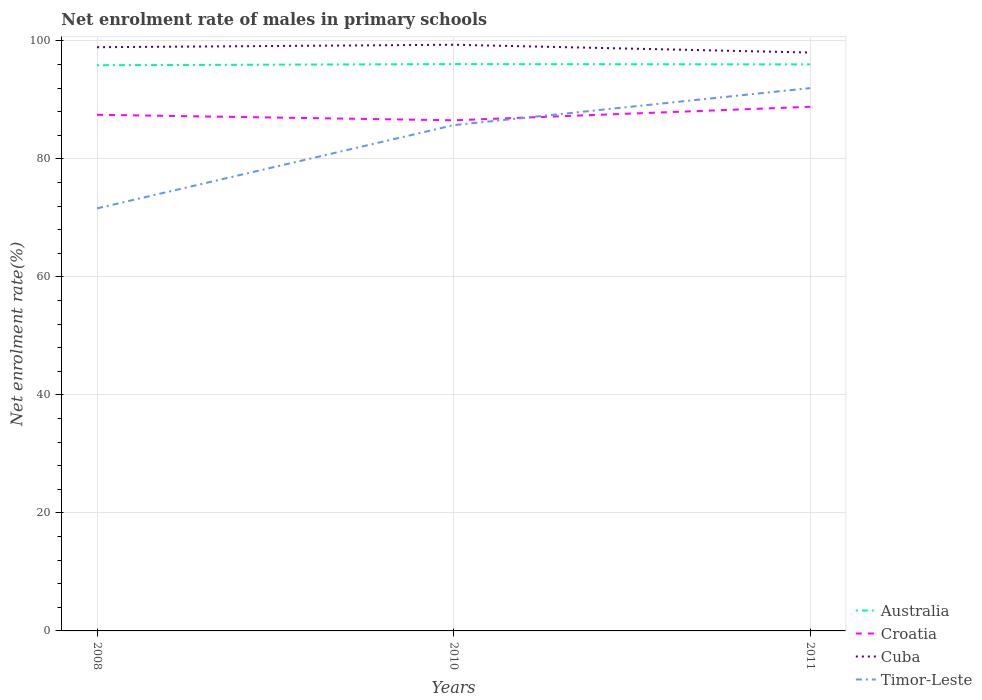How many different coloured lines are there?
Make the answer very short. 4. Across all years, what is the maximum net enrolment rate of males in primary schools in Croatia?
Keep it short and to the point. 86.55. What is the total net enrolment rate of males in primary schools in Timor-Leste in the graph?
Make the answer very short. -20.39. What is the difference between the highest and the second highest net enrolment rate of males in primary schools in Cuba?
Give a very brief answer. 1.32. How many years are there in the graph?
Keep it short and to the point. 3. Are the values on the major ticks of Y-axis written in scientific E-notation?
Your answer should be compact. No. Does the graph contain any zero values?
Ensure brevity in your answer.  No. Does the graph contain grids?
Provide a short and direct response. Yes. Where does the legend appear in the graph?
Your response must be concise. Bottom right. How many legend labels are there?
Keep it short and to the point. 4. What is the title of the graph?
Your answer should be compact. Net enrolment rate of males in primary schools. What is the label or title of the X-axis?
Ensure brevity in your answer.  Years. What is the label or title of the Y-axis?
Make the answer very short. Net enrolment rate(%). What is the Net enrolment rate(%) in Australia in 2008?
Ensure brevity in your answer.  95.89. What is the Net enrolment rate(%) in Croatia in 2008?
Provide a short and direct response. 87.49. What is the Net enrolment rate(%) in Cuba in 2008?
Your response must be concise. 98.94. What is the Net enrolment rate(%) in Timor-Leste in 2008?
Make the answer very short. 71.63. What is the Net enrolment rate(%) in Australia in 2010?
Your response must be concise. 96.09. What is the Net enrolment rate(%) in Croatia in 2010?
Provide a succinct answer. 86.55. What is the Net enrolment rate(%) of Cuba in 2010?
Your answer should be very brief. 99.36. What is the Net enrolment rate(%) in Timor-Leste in 2010?
Your response must be concise. 85.73. What is the Net enrolment rate(%) in Australia in 2011?
Your answer should be very brief. 96.03. What is the Net enrolment rate(%) in Croatia in 2011?
Keep it short and to the point. 88.85. What is the Net enrolment rate(%) of Cuba in 2011?
Keep it short and to the point. 98.04. What is the Net enrolment rate(%) in Timor-Leste in 2011?
Offer a very short reply. 92.02. Across all years, what is the maximum Net enrolment rate(%) of Australia?
Keep it short and to the point. 96.09. Across all years, what is the maximum Net enrolment rate(%) in Croatia?
Your response must be concise. 88.85. Across all years, what is the maximum Net enrolment rate(%) in Cuba?
Make the answer very short. 99.36. Across all years, what is the maximum Net enrolment rate(%) in Timor-Leste?
Ensure brevity in your answer.  92.02. Across all years, what is the minimum Net enrolment rate(%) of Australia?
Offer a very short reply. 95.89. Across all years, what is the minimum Net enrolment rate(%) in Croatia?
Provide a succinct answer. 86.55. Across all years, what is the minimum Net enrolment rate(%) in Cuba?
Keep it short and to the point. 98.04. Across all years, what is the minimum Net enrolment rate(%) of Timor-Leste?
Ensure brevity in your answer.  71.63. What is the total Net enrolment rate(%) in Australia in the graph?
Provide a succinct answer. 288.01. What is the total Net enrolment rate(%) in Croatia in the graph?
Provide a short and direct response. 262.89. What is the total Net enrolment rate(%) of Cuba in the graph?
Provide a short and direct response. 296.35. What is the total Net enrolment rate(%) of Timor-Leste in the graph?
Provide a succinct answer. 249.37. What is the difference between the Net enrolment rate(%) of Australia in 2008 and that in 2010?
Your answer should be very brief. -0.2. What is the difference between the Net enrolment rate(%) of Croatia in 2008 and that in 2010?
Your response must be concise. 0.94. What is the difference between the Net enrolment rate(%) in Cuba in 2008 and that in 2010?
Make the answer very short. -0.42. What is the difference between the Net enrolment rate(%) of Timor-Leste in 2008 and that in 2010?
Make the answer very short. -14.11. What is the difference between the Net enrolment rate(%) in Australia in 2008 and that in 2011?
Provide a short and direct response. -0.15. What is the difference between the Net enrolment rate(%) of Croatia in 2008 and that in 2011?
Ensure brevity in your answer.  -1.36. What is the difference between the Net enrolment rate(%) in Cuba in 2008 and that in 2011?
Offer a very short reply. 0.9. What is the difference between the Net enrolment rate(%) of Timor-Leste in 2008 and that in 2011?
Offer a terse response. -20.39. What is the difference between the Net enrolment rate(%) of Australia in 2010 and that in 2011?
Make the answer very short. 0.05. What is the difference between the Net enrolment rate(%) of Croatia in 2010 and that in 2011?
Provide a short and direct response. -2.29. What is the difference between the Net enrolment rate(%) of Cuba in 2010 and that in 2011?
Ensure brevity in your answer.  1.32. What is the difference between the Net enrolment rate(%) in Timor-Leste in 2010 and that in 2011?
Your response must be concise. -6.28. What is the difference between the Net enrolment rate(%) of Australia in 2008 and the Net enrolment rate(%) of Croatia in 2010?
Provide a succinct answer. 9.33. What is the difference between the Net enrolment rate(%) in Australia in 2008 and the Net enrolment rate(%) in Cuba in 2010?
Your response must be concise. -3.47. What is the difference between the Net enrolment rate(%) in Australia in 2008 and the Net enrolment rate(%) in Timor-Leste in 2010?
Provide a succinct answer. 10.16. What is the difference between the Net enrolment rate(%) in Croatia in 2008 and the Net enrolment rate(%) in Cuba in 2010?
Make the answer very short. -11.87. What is the difference between the Net enrolment rate(%) of Croatia in 2008 and the Net enrolment rate(%) of Timor-Leste in 2010?
Your answer should be compact. 1.76. What is the difference between the Net enrolment rate(%) in Cuba in 2008 and the Net enrolment rate(%) in Timor-Leste in 2010?
Ensure brevity in your answer.  13.21. What is the difference between the Net enrolment rate(%) in Australia in 2008 and the Net enrolment rate(%) in Croatia in 2011?
Your answer should be very brief. 7.04. What is the difference between the Net enrolment rate(%) in Australia in 2008 and the Net enrolment rate(%) in Cuba in 2011?
Offer a very short reply. -2.15. What is the difference between the Net enrolment rate(%) in Australia in 2008 and the Net enrolment rate(%) in Timor-Leste in 2011?
Your answer should be very brief. 3.87. What is the difference between the Net enrolment rate(%) in Croatia in 2008 and the Net enrolment rate(%) in Cuba in 2011?
Make the answer very short. -10.55. What is the difference between the Net enrolment rate(%) in Croatia in 2008 and the Net enrolment rate(%) in Timor-Leste in 2011?
Offer a very short reply. -4.53. What is the difference between the Net enrolment rate(%) of Cuba in 2008 and the Net enrolment rate(%) of Timor-Leste in 2011?
Keep it short and to the point. 6.93. What is the difference between the Net enrolment rate(%) of Australia in 2010 and the Net enrolment rate(%) of Croatia in 2011?
Keep it short and to the point. 7.24. What is the difference between the Net enrolment rate(%) of Australia in 2010 and the Net enrolment rate(%) of Cuba in 2011?
Provide a short and direct response. -1.96. What is the difference between the Net enrolment rate(%) in Australia in 2010 and the Net enrolment rate(%) in Timor-Leste in 2011?
Provide a short and direct response. 4.07. What is the difference between the Net enrolment rate(%) of Croatia in 2010 and the Net enrolment rate(%) of Cuba in 2011?
Your response must be concise. -11.49. What is the difference between the Net enrolment rate(%) in Croatia in 2010 and the Net enrolment rate(%) in Timor-Leste in 2011?
Ensure brevity in your answer.  -5.46. What is the difference between the Net enrolment rate(%) in Cuba in 2010 and the Net enrolment rate(%) in Timor-Leste in 2011?
Your answer should be very brief. 7.35. What is the average Net enrolment rate(%) in Australia per year?
Your response must be concise. 96. What is the average Net enrolment rate(%) of Croatia per year?
Offer a terse response. 87.63. What is the average Net enrolment rate(%) in Cuba per year?
Offer a terse response. 98.78. What is the average Net enrolment rate(%) of Timor-Leste per year?
Give a very brief answer. 83.12. In the year 2008, what is the difference between the Net enrolment rate(%) of Australia and Net enrolment rate(%) of Croatia?
Offer a very short reply. 8.4. In the year 2008, what is the difference between the Net enrolment rate(%) of Australia and Net enrolment rate(%) of Cuba?
Your answer should be very brief. -3.06. In the year 2008, what is the difference between the Net enrolment rate(%) in Australia and Net enrolment rate(%) in Timor-Leste?
Offer a very short reply. 24.26. In the year 2008, what is the difference between the Net enrolment rate(%) in Croatia and Net enrolment rate(%) in Cuba?
Your answer should be compact. -11.45. In the year 2008, what is the difference between the Net enrolment rate(%) in Croatia and Net enrolment rate(%) in Timor-Leste?
Keep it short and to the point. 15.86. In the year 2008, what is the difference between the Net enrolment rate(%) of Cuba and Net enrolment rate(%) of Timor-Leste?
Make the answer very short. 27.32. In the year 2010, what is the difference between the Net enrolment rate(%) in Australia and Net enrolment rate(%) in Croatia?
Provide a short and direct response. 9.53. In the year 2010, what is the difference between the Net enrolment rate(%) of Australia and Net enrolment rate(%) of Cuba?
Ensure brevity in your answer.  -3.28. In the year 2010, what is the difference between the Net enrolment rate(%) of Australia and Net enrolment rate(%) of Timor-Leste?
Give a very brief answer. 10.35. In the year 2010, what is the difference between the Net enrolment rate(%) in Croatia and Net enrolment rate(%) in Cuba?
Your response must be concise. -12.81. In the year 2010, what is the difference between the Net enrolment rate(%) in Croatia and Net enrolment rate(%) in Timor-Leste?
Make the answer very short. 0.82. In the year 2010, what is the difference between the Net enrolment rate(%) of Cuba and Net enrolment rate(%) of Timor-Leste?
Your answer should be compact. 13.63. In the year 2011, what is the difference between the Net enrolment rate(%) in Australia and Net enrolment rate(%) in Croatia?
Make the answer very short. 7.19. In the year 2011, what is the difference between the Net enrolment rate(%) in Australia and Net enrolment rate(%) in Cuba?
Ensure brevity in your answer.  -2.01. In the year 2011, what is the difference between the Net enrolment rate(%) of Australia and Net enrolment rate(%) of Timor-Leste?
Your answer should be very brief. 4.02. In the year 2011, what is the difference between the Net enrolment rate(%) in Croatia and Net enrolment rate(%) in Cuba?
Make the answer very short. -9.2. In the year 2011, what is the difference between the Net enrolment rate(%) of Croatia and Net enrolment rate(%) of Timor-Leste?
Offer a very short reply. -3.17. In the year 2011, what is the difference between the Net enrolment rate(%) of Cuba and Net enrolment rate(%) of Timor-Leste?
Offer a very short reply. 6.03. What is the ratio of the Net enrolment rate(%) of Croatia in 2008 to that in 2010?
Offer a terse response. 1.01. What is the ratio of the Net enrolment rate(%) of Cuba in 2008 to that in 2010?
Give a very brief answer. 1. What is the ratio of the Net enrolment rate(%) of Timor-Leste in 2008 to that in 2010?
Ensure brevity in your answer.  0.84. What is the ratio of the Net enrolment rate(%) in Australia in 2008 to that in 2011?
Ensure brevity in your answer.  1. What is the ratio of the Net enrolment rate(%) in Croatia in 2008 to that in 2011?
Provide a short and direct response. 0.98. What is the ratio of the Net enrolment rate(%) in Cuba in 2008 to that in 2011?
Offer a very short reply. 1.01. What is the ratio of the Net enrolment rate(%) of Timor-Leste in 2008 to that in 2011?
Ensure brevity in your answer.  0.78. What is the ratio of the Net enrolment rate(%) in Croatia in 2010 to that in 2011?
Ensure brevity in your answer.  0.97. What is the ratio of the Net enrolment rate(%) of Cuba in 2010 to that in 2011?
Give a very brief answer. 1.01. What is the ratio of the Net enrolment rate(%) of Timor-Leste in 2010 to that in 2011?
Ensure brevity in your answer.  0.93. What is the difference between the highest and the second highest Net enrolment rate(%) in Australia?
Make the answer very short. 0.05. What is the difference between the highest and the second highest Net enrolment rate(%) in Croatia?
Give a very brief answer. 1.36. What is the difference between the highest and the second highest Net enrolment rate(%) of Cuba?
Ensure brevity in your answer.  0.42. What is the difference between the highest and the second highest Net enrolment rate(%) in Timor-Leste?
Your response must be concise. 6.28. What is the difference between the highest and the lowest Net enrolment rate(%) of Australia?
Offer a terse response. 0.2. What is the difference between the highest and the lowest Net enrolment rate(%) in Croatia?
Your response must be concise. 2.29. What is the difference between the highest and the lowest Net enrolment rate(%) in Cuba?
Your answer should be compact. 1.32. What is the difference between the highest and the lowest Net enrolment rate(%) of Timor-Leste?
Provide a succinct answer. 20.39. 